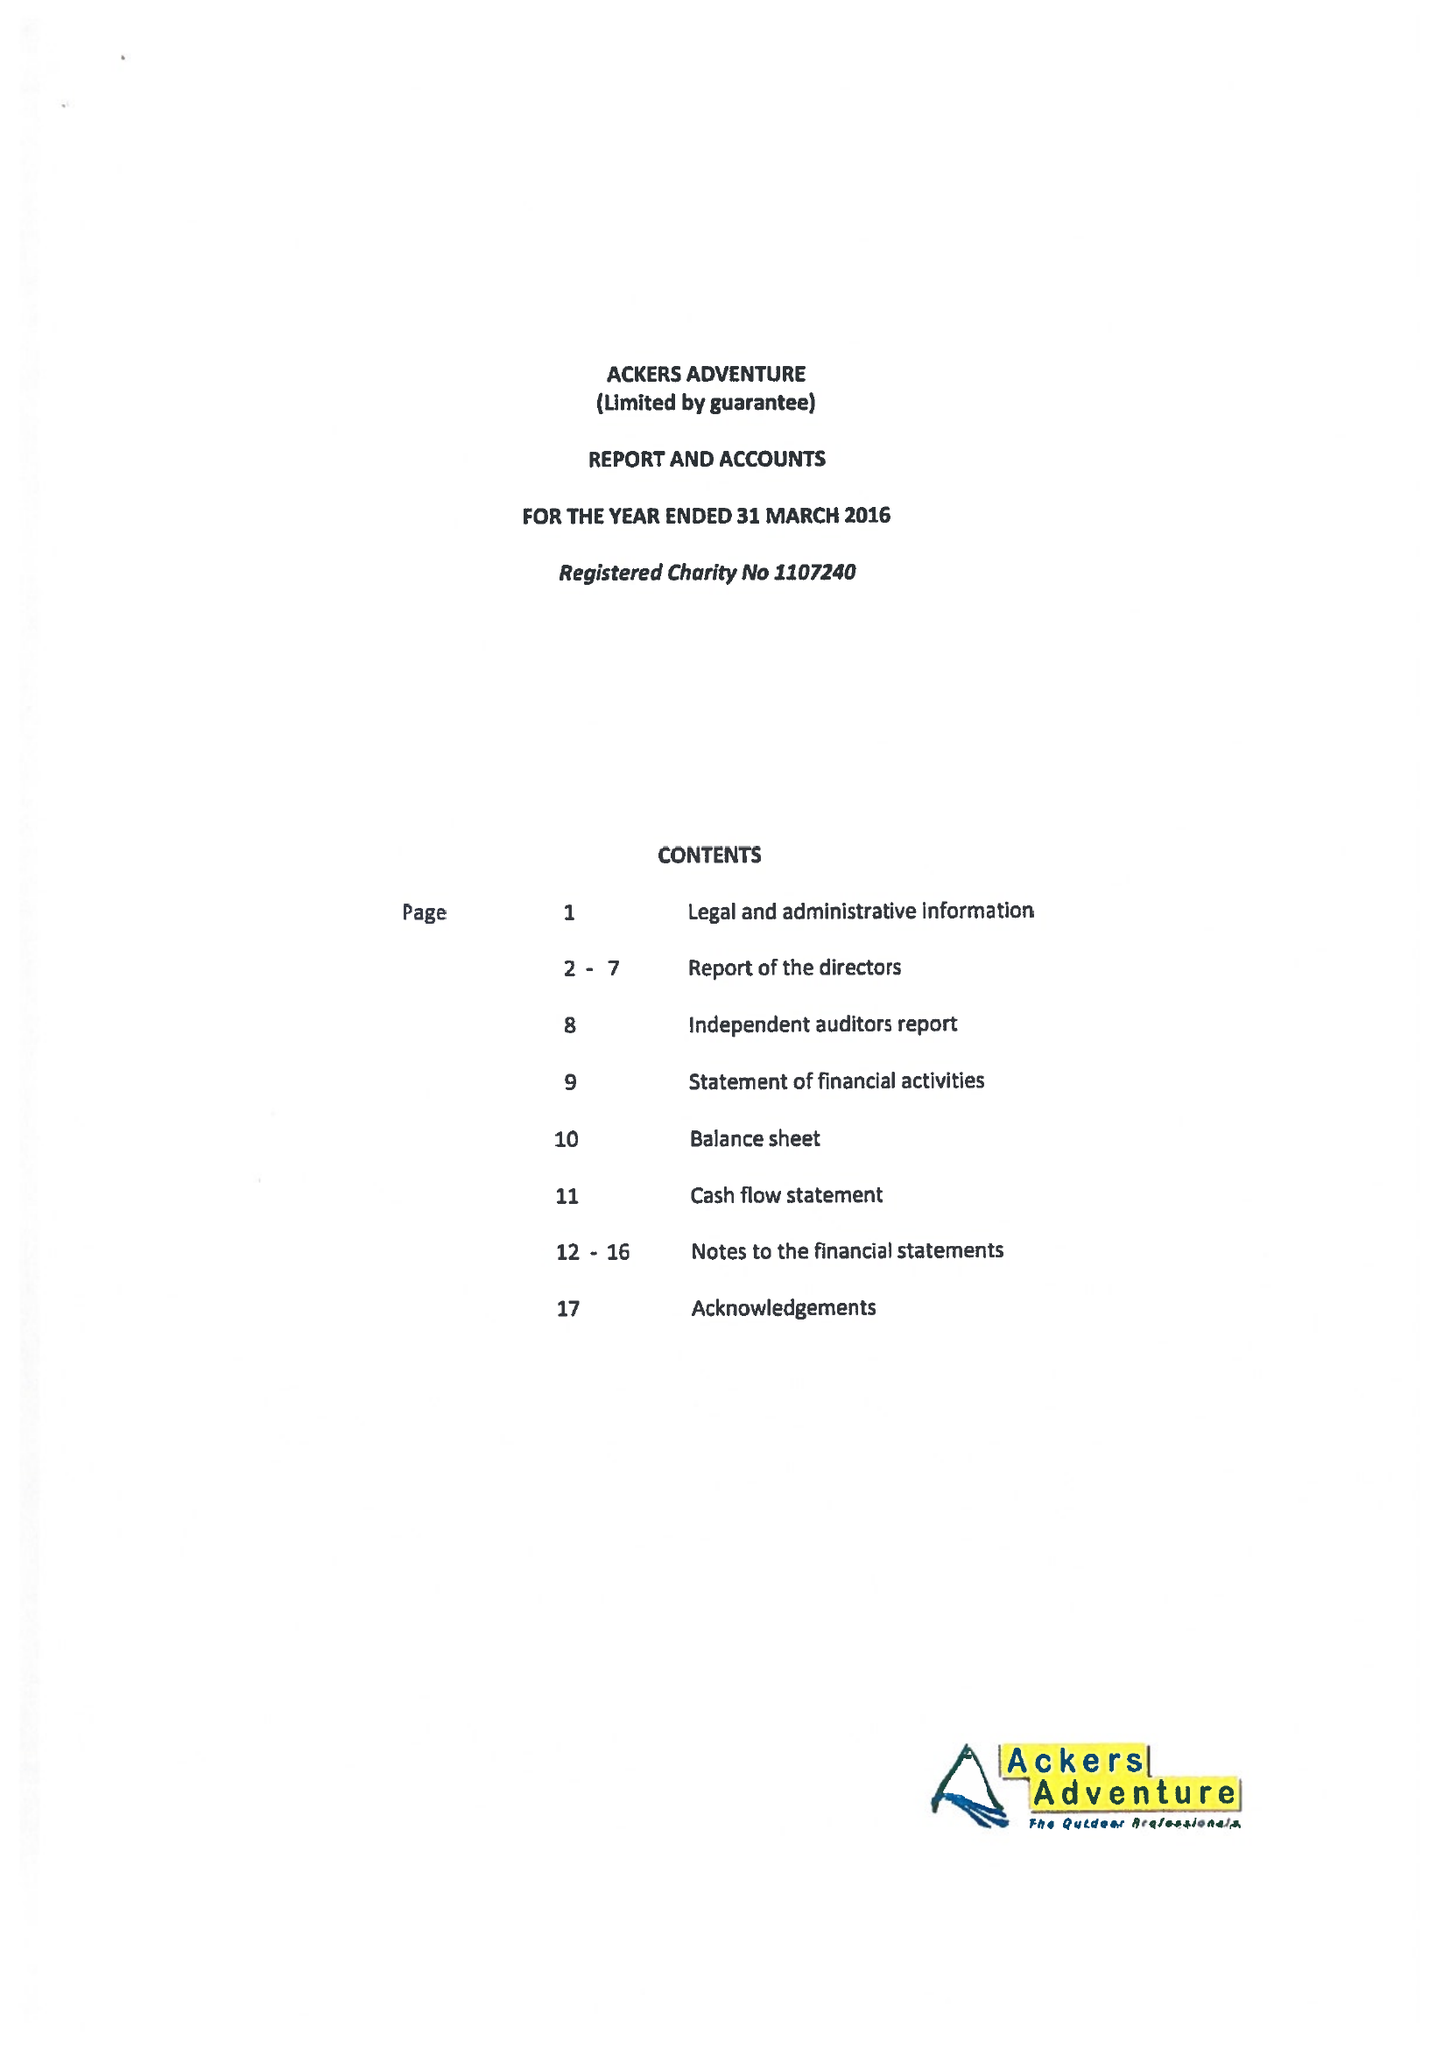What is the value for the charity_name?
Answer the question using a single word or phrase. Ackers Adventure 